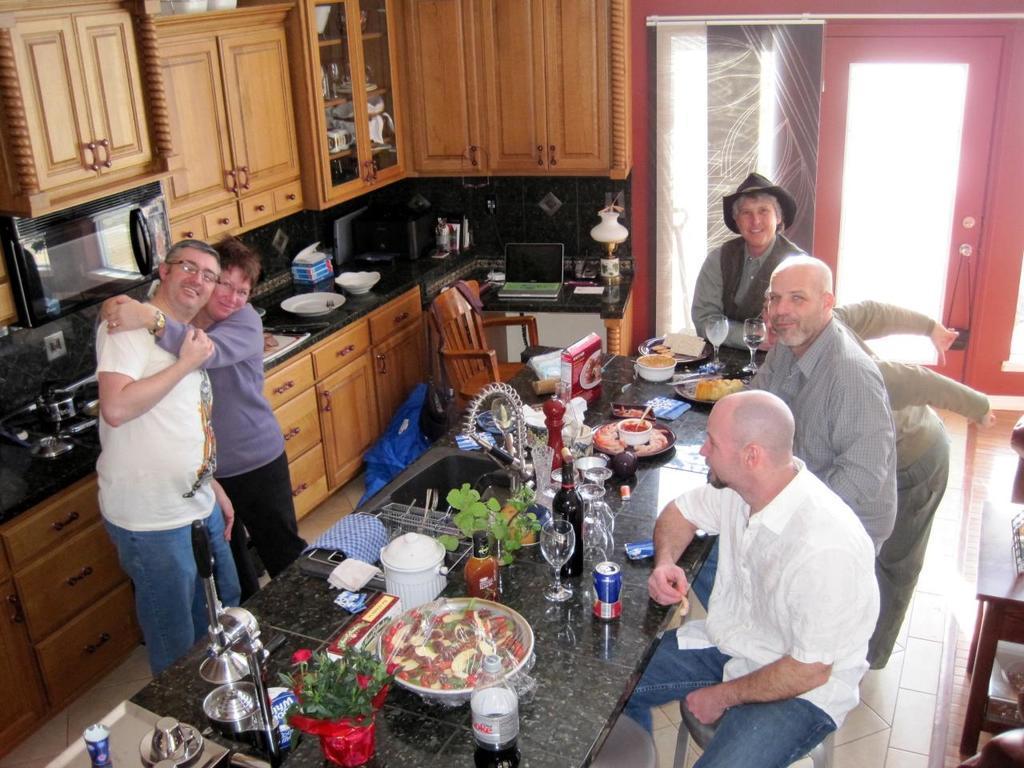Could you give a brief overview of what you see in this image? In this image I can see few persons. I can see a dining table. There are few food items and drinks on the table. I can see two persons standing. In the background I can see few cupboards. 